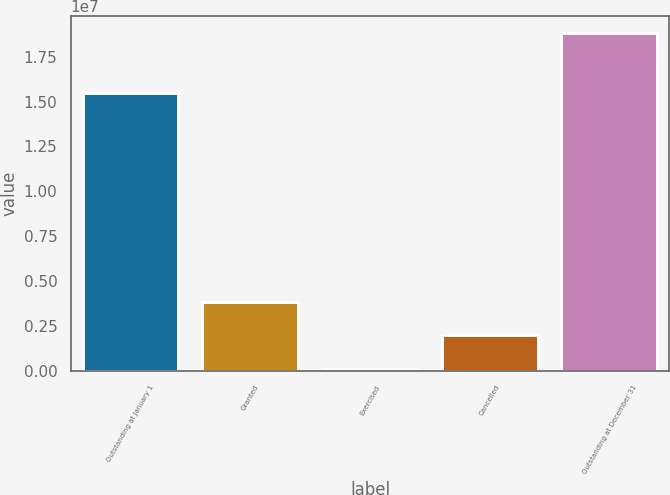Convert chart to OTSL. <chart><loc_0><loc_0><loc_500><loc_500><bar_chart><fcel>Outstanding at January 1<fcel>Granted<fcel>Exercised<fcel>Cancelled<fcel>Outstanding at December 31<nl><fcel>1.54531e+07<fcel>3.85062e+06<fcel>114181<fcel>1.9824e+06<fcel>1.87964e+07<nl></chart> 